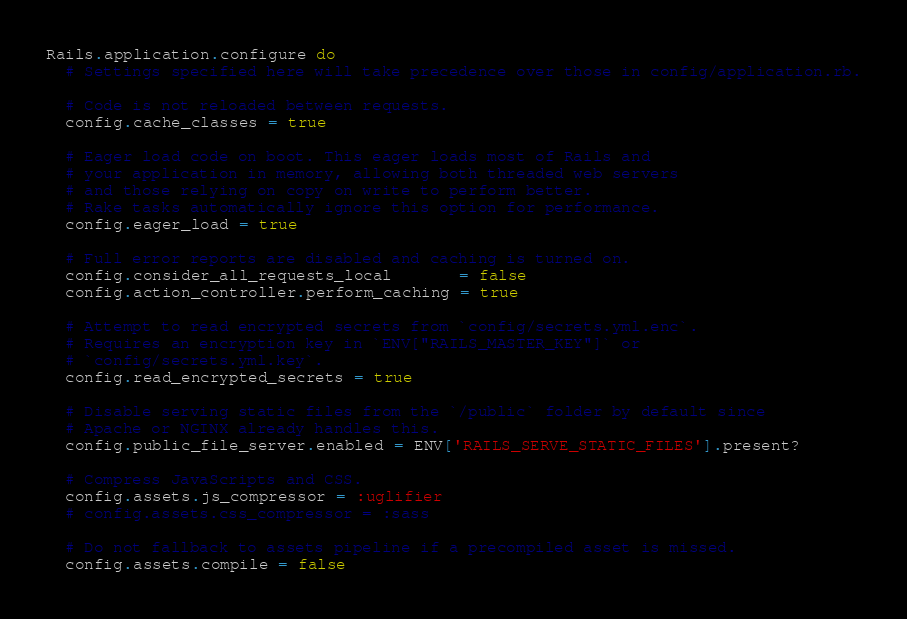Convert code to text. <code><loc_0><loc_0><loc_500><loc_500><_Ruby_>Rails.application.configure do
  # Settings specified here will take precedence over those in config/application.rb.

  # Code is not reloaded between requests.
  config.cache_classes = true

  # Eager load code on boot. This eager loads most of Rails and
  # your application in memory, allowing both threaded web servers
  # and those relying on copy on write to perform better.
  # Rake tasks automatically ignore this option for performance.
  config.eager_load = true

  # Full error reports are disabled and caching is turned on.
  config.consider_all_requests_local       = false
  config.action_controller.perform_caching = true

  # Attempt to read encrypted secrets from `config/secrets.yml.enc`.
  # Requires an encryption key in `ENV["RAILS_MASTER_KEY"]` or
  # `config/secrets.yml.key`.
  config.read_encrypted_secrets = true

  # Disable serving static files from the `/public` folder by default since
  # Apache or NGINX already handles this.
  config.public_file_server.enabled = ENV['RAILS_SERVE_STATIC_FILES'].present?

  # Compress JavaScripts and CSS.
  config.assets.js_compressor = :uglifier
  # config.assets.css_compressor = :sass

  # Do not fallback to assets pipeline if a precompiled asset is missed.
  config.assets.compile = false
</code> 